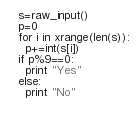Convert code to text. <code><loc_0><loc_0><loc_500><loc_500><_Python_>s=raw_input()
p=0
for i in xrange(len(s)):
  p+=int(s[i])
if p%9==0:
  print "Yes"
else:
  print "No"
  </code> 